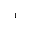<formula> <loc_0><loc_0><loc_500><loc_500>^ { 1 }</formula> 